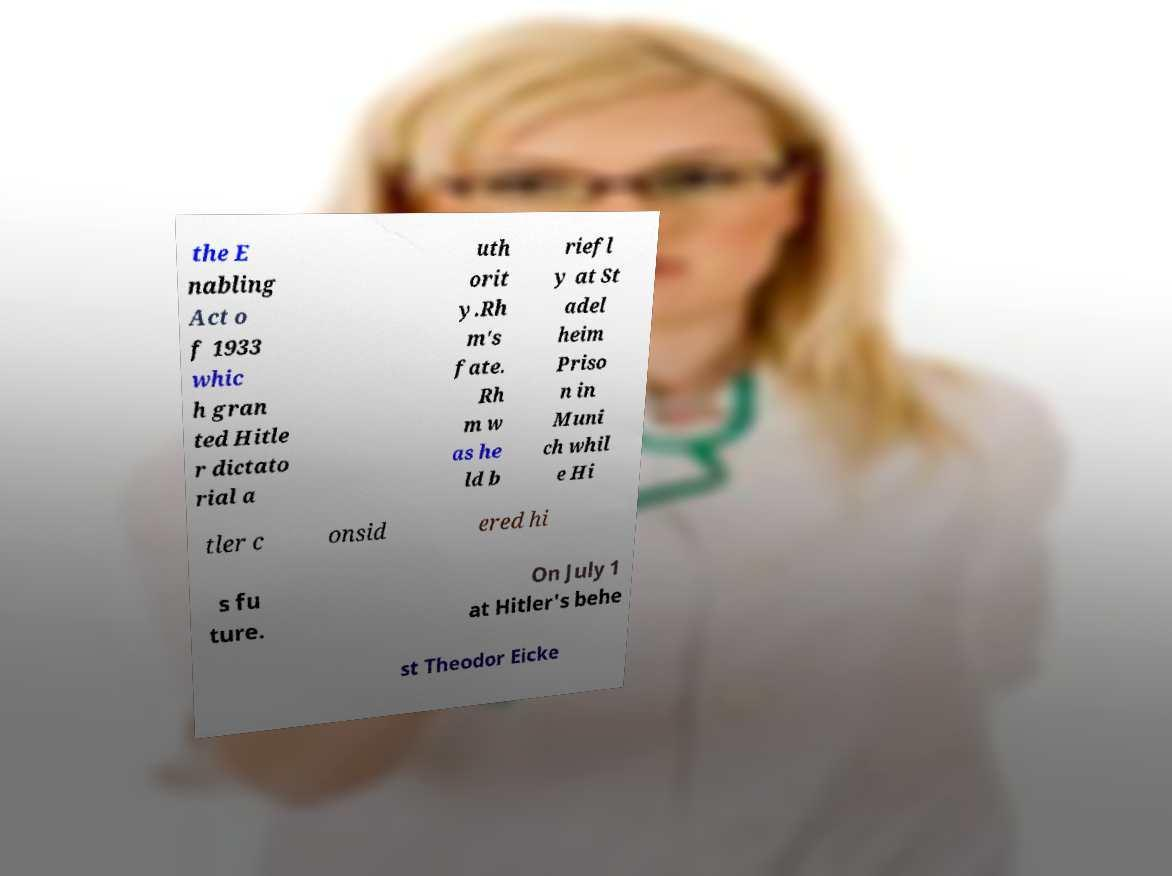There's text embedded in this image that I need extracted. Can you transcribe it verbatim? the E nabling Act o f 1933 whic h gran ted Hitle r dictato rial a uth orit y.Rh m's fate. Rh m w as he ld b riefl y at St adel heim Priso n in Muni ch whil e Hi tler c onsid ered hi s fu ture. On July 1 at Hitler's behe st Theodor Eicke 